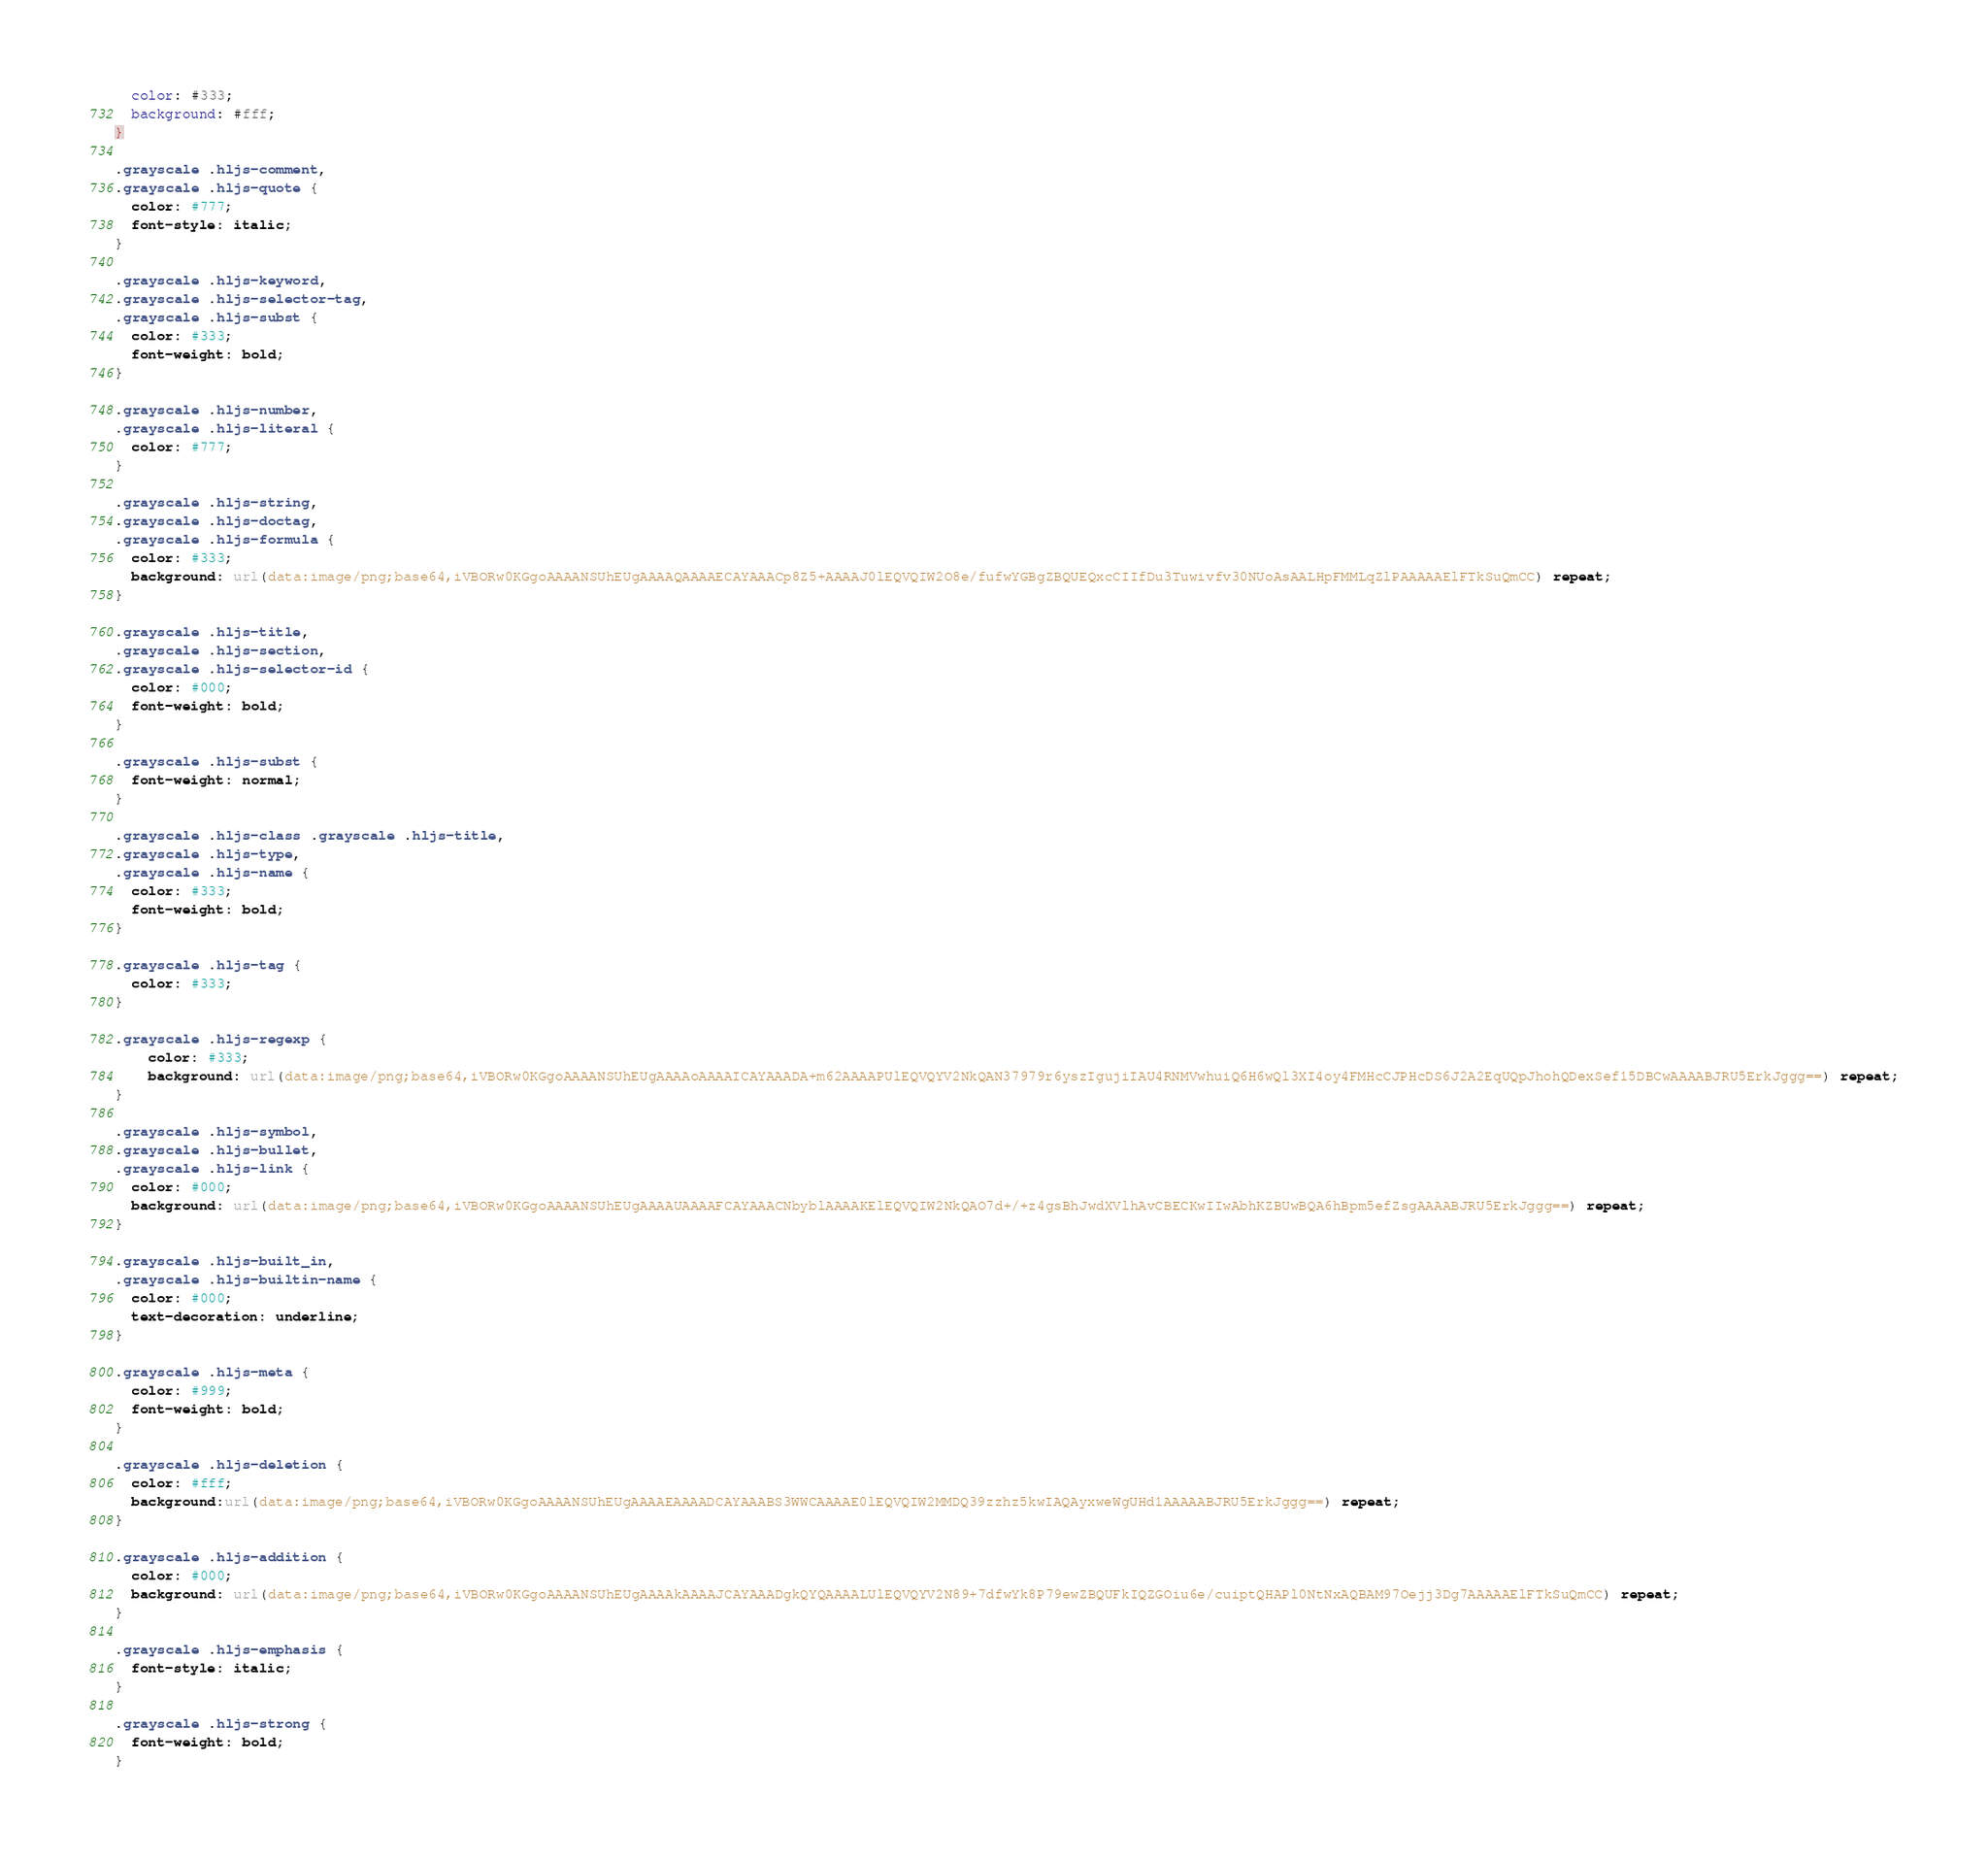<code> <loc_0><loc_0><loc_500><loc_500><_CSS_>  color: #333;
  background: #fff;
}

.grayscale .hljs-comment,
.grayscale .hljs-quote {
  color: #777;
  font-style: italic;
}

.grayscale .hljs-keyword,
.grayscale .hljs-selector-tag,
.grayscale .hljs-subst {
  color: #333;
  font-weight: bold;
}

.grayscale .hljs-number,
.grayscale .hljs-literal {
  color: #777;
}

.grayscale .hljs-string,
.grayscale .hljs-doctag,
.grayscale .hljs-formula {
  color: #333;
  background: url(data:image/png;base64,iVBORw0KGgoAAAANSUhEUgAAAAQAAAAECAYAAACp8Z5+AAAAJ0lEQVQIW2O8e/fufwYGBgZBQUEQxcCIIfDu3Tuwivfv30NUoAsAALHpFMMLqZlPAAAAAElFTkSuQmCC) repeat;
}

.grayscale .hljs-title,
.grayscale .hljs-section,
.grayscale .hljs-selector-id {
  color: #000;
  font-weight: bold;
}

.grayscale .hljs-subst {
  font-weight: normal;
}

.grayscale .hljs-class .grayscale .hljs-title,
.grayscale .hljs-type,
.grayscale .hljs-name {
  color: #333;
  font-weight: bold;
}

.grayscale .hljs-tag {
  color: #333;
}

.grayscale .hljs-regexp {
    color: #333;
    background: url(data:image/png;base64,iVBORw0KGgoAAAANSUhEUgAAAAoAAAAICAYAAADA+m62AAAAPUlEQVQYV2NkQAN37979r6yszIgujiIAU4RNMVwhuiQ6H6wQl3XI4oy4FMHcCJPHcDS6J2A2EqUQpJhohQDexSef15DBCwAAAABJRU5ErkJggg==) repeat;
}

.grayscale .hljs-symbol,
.grayscale .hljs-bullet,
.grayscale .hljs-link {
  color: #000;
  background: url(data:image/png;base64,iVBORw0KGgoAAAANSUhEUgAAAAUAAAAFCAYAAACNbyblAAAAKElEQVQIW2NkQAO7d+/+z4gsBhJwdXVlhAvCBECKwIIwAbhKZBUwBQA6hBpm5efZsgAAAABJRU5ErkJggg==) repeat;
}

.grayscale .hljs-built_in,
.grayscale .hljs-builtin-name {
  color: #000;
  text-decoration: underline;
}

.grayscale .hljs-meta {
  color: #999;
  font-weight: bold;
}

.grayscale .hljs-deletion {
  color: #fff;
  background:url(data:image/png;base64,iVBORw0KGgoAAAANSUhEUgAAAAEAAAADCAYAAABS3WWCAAAAE0lEQVQIW2MMDQ39zzhz5kwIAQAyxweWgUHd1AAAAABJRU5ErkJggg==) repeat;
}

.grayscale .hljs-addition {
  color: #000;
  background: url(data:image/png;base64,iVBORw0KGgoAAAANSUhEUgAAAAkAAAAJCAYAAADgkQYQAAAALUlEQVQYV2N89+7dfwYk8P79ewZBQUFkIQZGOiu6e/cuiptQHAPl0NtNxAQBAM97Oejj3Dg7AAAAAElFTkSuQmCC) repeat;
}

.grayscale .hljs-emphasis {
  font-style: italic;
}

.grayscale .hljs-strong {
  font-weight: bold;
}
</code> 